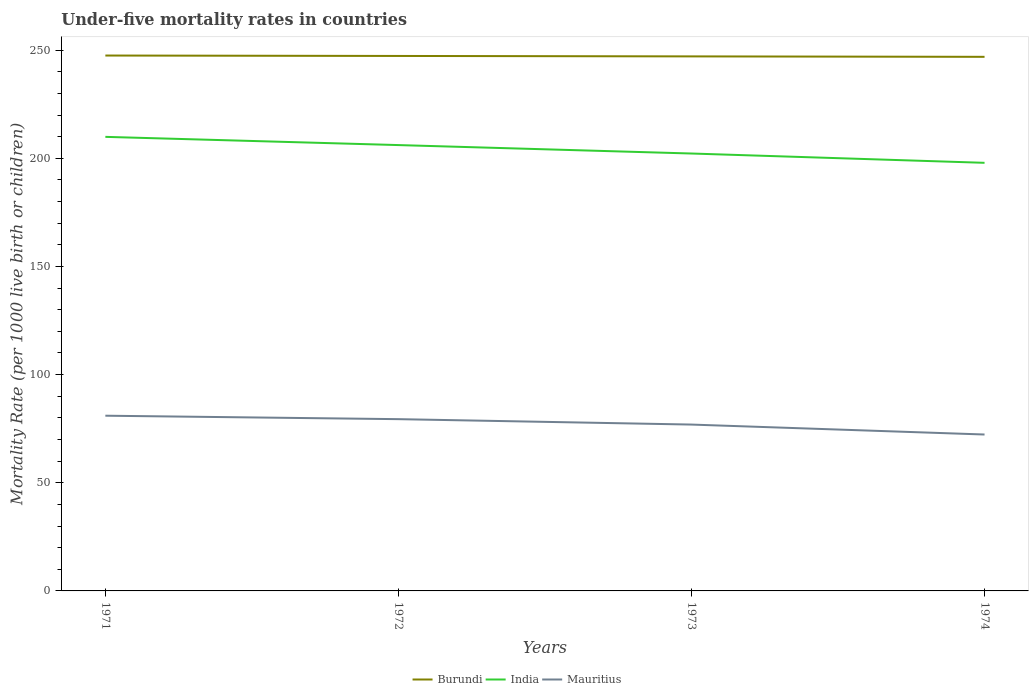How many different coloured lines are there?
Keep it short and to the point. 3. Does the line corresponding to Mauritius intersect with the line corresponding to Burundi?
Your answer should be compact. No. Across all years, what is the maximum under-five mortality rate in India?
Make the answer very short. 197.9. In which year was the under-five mortality rate in Burundi maximum?
Provide a succinct answer. 1974. What is the total under-five mortality rate in Mauritius in the graph?
Your answer should be very brief. 4.6. What is the difference between the highest and the lowest under-five mortality rate in India?
Offer a terse response. 2. How many lines are there?
Offer a terse response. 3. Does the graph contain any zero values?
Your answer should be compact. No. Where does the legend appear in the graph?
Your answer should be compact. Bottom center. How are the legend labels stacked?
Offer a very short reply. Horizontal. What is the title of the graph?
Your response must be concise. Under-five mortality rates in countries. Does "Turkmenistan" appear as one of the legend labels in the graph?
Your answer should be compact. No. What is the label or title of the X-axis?
Your response must be concise. Years. What is the label or title of the Y-axis?
Provide a short and direct response. Mortality Rate (per 1000 live birth or children). What is the Mortality Rate (per 1000 live birth or children) in Burundi in 1971?
Make the answer very short. 247.5. What is the Mortality Rate (per 1000 live birth or children) in India in 1971?
Your answer should be very brief. 209.9. What is the Mortality Rate (per 1000 live birth or children) in Mauritius in 1971?
Provide a succinct answer. 81. What is the Mortality Rate (per 1000 live birth or children) in Burundi in 1972?
Keep it short and to the point. 247.3. What is the Mortality Rate (per 1000 live birth or children) of India in 1972?
Give a very brief answer. 206.1. What is the Mortality Rate (per 1000 live birth or children) of Mauritius in 1972?
Provide a short and direct response. 79.4. What is the Mortality Rate (per 1000 live birth or children) in Burundi in 1973?
Give a very brief answer. 247.1. What is the Mortality Rate (per 1000 live birth or children) of India in 1973?
Give a very brief answer. 202.2. What is the Mortality Rate (per 1000 live birth or children) in Mauritius in 1973?
Offer a very short reply. 76.9. What is the Mortality Rate (per 1000 live birth or children) in Burundi in 1974?
Your answer should be very brief. 246.9. What is the Mortality Rate (per 1000 live birth or children) of India in 1974?
Your answer should be compact. 197.9. What is the Mortality Rate (per 1000 live birth or children) in Mauritius in 1974?
Provide a short and direct response. 72.3. Across all years, what is the maximum Mortality Rate (per 1000 live birth or children) of Burundi?
Provide a short and direct response. 247.5. Across all years, what is the maximum Mortality Rate (per 1000 live birth or children) in India?
Provide a succinct answer. 209.9. Across all years, what is the maximum Mortality Rate (per 1000 live birth or children) of Mauritius?
Provide a succinct answer. 81. Across all years, what is the minimum Mortality Rate (per 1000 live birth or children) of Burundi?
Offer a very short reply. 246.9. Across all years, what is the minimum Mortality Rate (per 1000 live birth or children) of India?
Your answer should be compact. 197.9. Across all years, what is the minimum Mortality Rate (per 1000 live birth or children) of Mauritius?
Your response must be concise. 72.3. What is the total Mortality Rate (per 1000 live birth or children) of Burundi in the graph?
Keep it short and to the point. 988.8. What is the total Mortality Rate (per 1000 live birth or children) in India in the graph?
Make the answer very short. 816.1. What is the total Mortality Rate (per 1000 live birth or children) of Mauritius in the graph?
Your answer should be very brief. 309.6. What is the difference between the Mortality Rate (per 1000 live birth or children) in Burundi in 1971 and that in 1972?
Provide a succinct answer. 0.2. What is the difference between the Mortality Rate (per 1000 live birth or children) in Mauritius in 1971 and that in 1972?
Provide a short and direct response. 1.6. What is the difference between the Mortality Rate (per 1000 live birth or children) of India in 1971 and that in 1973?
Offer a terse response. 7.7. What is the difference between the Mortality Rate (per 1000 live birth or children) of India in 1971 and that in 1974?
Keep it short and to the point. 12. What is the difference between the Mortality Rate (per 1000 live birth or children) of Burundi in 1973 and that in 1974?
Make the answer very short. 0.2. What is the difference between the Mortality Rate (per 1000 live birth or children) of India in 1973 and that in 1974?
Offer a very short reply. 4.3. What is the difference between the Mortality Rate (per 1000 live birth or children) in Mauritius in 1973 and that in 1974?
Offer a very short reply. 4.6. What is the difference between the Mortality Rate (per 1000 live birth or children) of Burundi in 1971 and the Mortality Rate (per 1000 live birth or children) of India in 1972?
Your response must be concise. 41.4. What is the difference between the Mortality Rate (per 1000 live birth or children) of Burundi in 1971 and the Mortality Rate (per 1000 live birth or children) of Mauritius in 1972?
Provide a short and direct response. 168.1. What is the difference between the Mortality Rate (per 1000 live birth or children) of India in 1971 and the Mortality Rate (per 1000 live birth or children) of Mauritius in 1972?
Provide a succinct answer. 130.5. What is the difference between the Mortality Rate (per 1000 live birth or children) in Burundi in 1971 and the Mortality Rate (per 1000 live birth or children) in India in 1973?
Offer a very short reply. 45.3. What is the difference between the Mortality Rate (per 1000 live birth or children) of Burundi in 1971 and the Mortality Rate (per 1000 live birth or children) of Mauritius in 1973?
Give a very brief answer. 170.6. What is the difference between the Mortality Rate (per 1000 live birth or children) in India in 1971 and the Mortality Rate (per 1000 live birth or children) in Mauritius in 1973?
Provide a short and direct response. 133. What is the difference between the Mortality Rate (per 1000 live birth or children) in Burundi in 1971 and the Mortality Rate (per 1000 live birth or children) in India in 1974?
Offer a terse response. 49.6. What is the difference between the Mortality Rate (per 1000 live birth or children) of Burundi in 1971 and the Mortality Rate (per 1000 live birth or children) of Mauritius in 1974?
Your answer should be compact. 175.2. What is the difference between the Mortality Rate (per 1000 live birth or children) in India in 1971 and the Mortality Rate (per 1000 live birth or children) in Mauritius in 1974?
Your answer should be very brief. 137.6. What is the difference between the Mortality Rate (per 1000 live birth or children) of Burundi in 1972 and the Mortality Rate (per 1000 live birth or children) of India in 1973?
Your answer should be compact. 45.1. What is the difference between the Mortality Rate (per 1000 live birth or children) of Burundi in 1972 and the Mortality Rate (per 1000 live birth or children) of Mauritius in 1973?
Provide a succinct answer. 170.4. What is the difference between the Mortality Rate (per 1000 live birth or children) in India in 1972 and the Mortality Rate (per 1000 live birth or children) in Mauritius in 1973?
Your answer should be compact. 129.2. What is the difference between the Mortality Rate (per 1000 live birth or children) in Burundi in 1972 and the Mortality Rate (per 1000 live birth or children) in India in 1974?
Your answer should be very brief. 49.4. What is the difference between the Mortality Rate (per 1000 live birth or children) in Burundi in 1972 and the Mortality Rate (per 1000 live birth or children) in Mauritius in 1974?
Make the answer very short. 175. What is the difference between the Mortality Rate (per 1000 live birth or children) of India in 1972 and the Mortality Rate (per 1000 live birth or children) of Mauritius in 1974?
Offer a very short reply. 133.8. What is the difference between the Mortality Rate (per 1000 live birth or children) of Burundi in 1973 and the Mortality Rate (per 1000 live birth or children) of India in 1974?
Keep it short and to the point. 49.2. What is the difference between the Mortality Rate (per 1000 live birth or children) in Burundi in 1973 and the Mortality Rate (per 1000 live birth or children) in Mauritius in 1974?
Provide a succinct answer. 174.8. What is the difference between the Mortality Rate (per 1000 live birth or children) of India in 1973 and the Mortality Rate (per 1000 live birth or children) of Mauritius in 1974?
Keep it short and to the point. 129.9. What is the average Mortality Rate (per 1000 live birth or children) in Burundi per year?
Your answer should be compact. 247.2. What is the average Mortality Rate (per 1000 live birth or children) of India per year?
Offer a very short reply. 204.03. What is the average Mortality Rate (per 1000 live birth or children) of Mauritius per year?
Offer a very short reply. 77.4. In the year 1971, what is the difference between the Mortality Rate (per 1000 live birth or children) in Burundi and Mortality Rate (per 1000 live birth or children) in India?
Offer a terse response. 37.6. In the year 1971, what is the difference between the Mortality Rate (per 1000 live birth or children) in Burundi and Mortality Rate (per 1000 live birth or children) in Mauritius?
Make the answer very short. 166.5. In the year 1971, what is the difference between the Mortality Rate (per 1000 live birth or children) of India and Mortality Rate (per 1000 live birth or children) of Mauritius?
Ensure brevity in your answer.  128.9. In the year 1972, what is the difference between the Mortality Rate (per 1000 live birth or children) in Burundi and Mortality Rate (per 1000 live birth or children) in India?
Give a very brief answer. 41.2. In the year 1972, what is the difference between the Mortality Rate (per 1000 live birth or children) of Burundi and Mortality Rate (per 1000 live birth or children) of Mauritius?
Provide a succinct answer. 167.9. In the year 1972, what is the difference between the Mortality Rate (per 1000 live birth or children) of India and Mortality Rate (per 1000 live birth or children) of Mauritius?
Your response must be concise. 126.7. In the year 1973, what is the difference between the Mortality Rate (per 1000 live birth or children) in Burundi and Mortality Rate (per 1000 live birth or children) in India?
Make the answer very short. 44.9. In the year 1973, what is the difference between the Mortality Rate (per 1000 live birth or children) of Burundi and Mortality Rate (per 1000 live birth or children) of Mauritius?
Your answer should be compact. 170.2. In the year 1973, what is the difference between the Mortality Rate (per 1000 live birth or children) in India and Mortality Rate (per 1000 live birth or children) in Mauritius?
Offer a terse response. 125.3. In the year 1974, what is the difference between the Mortality Rate (per 1000 live birth or children) of Burundi and Mortality Rate (per 1000 live birth or children) of Mauritius?
Keep it short and to the point. 174.6. In the year 1974, what is the difference between the Mortality Rate (per 1000 live birth or children) of India and Mortality Rate (per 1000 live birth or children) of Mauritius?
Give a very brief answer. 125.6. What is the ratio of the Mortality Rate (per 1000 live birth or children) in Burundi in 1971 to that in 1972?
Provide a short and direct response. 1. What is the ratio of the Mortality Rate (per 1000 live birth or children) in India in 1971 to that in 1972?
Your answer should be compact. 1.02. What is the ratio of the Mortality Rate (per 1000 live birth or children) of Mauritius in 1971 to that in 1972?
Ensure brevity in your answer.  1.02. What is the ratio of the Mortality Rate (per 1000 live birth or children) of India in 1971 to that in 1973?
Provide a succinct answer. 1.04. What is the ratio of the Mortality Rate (per 1000 live birth or children) in Mauritius in 1971 to that in 1973?
Keep it short and to the point. 1.05. What is the ratio of the Mortality Rate (per 1000 live birth or children) in India in 1971 to that in 1974?
Your answer should be very brief. 1.06. What is the ratio of the Mortality Rate (per 1000 live birth or children) of Mauritius in 1971 to that in 1974?
Make the answer very short. 1.12. What is the ratio of the Mortality Rate (per 1000 live birth or children) in India in 1972 to that in 1973?
Provide a short and direct response. 1.02. What is the ratio of the Mortality Rate (per 1000 live birth or children) in Mauritius in 1972 to that in 1973?
Give a very brief answer. 1.03. What is the ratio of the Mortality Rate (per 1000 live birth or children) of India in 1972 to that in 1974?
Provide a short and direct response. 1.04. What is the ratio of the Mortality Rate (per 1000 live birth or children) in Mauritius in 1972 to that in 1974?
Ensure brevity in your answer.  1.1. What is the ratio of the Mortality Rate (per 1000 live birth or children) of Burundi in 1973 to that in 1974?
Provide a succinct answer. 1. What is the ratio of the Mortality Rate (per 1000 live birth or children) of India in 1973 to that in 1974?
Ensure brevity in your answer.  1.02. What is the ratio of the Mortality Rate (per 1000 live birth or children) of Mauritius in 1973 to that in 1974?
Provide a succinct answer. 1.06. 